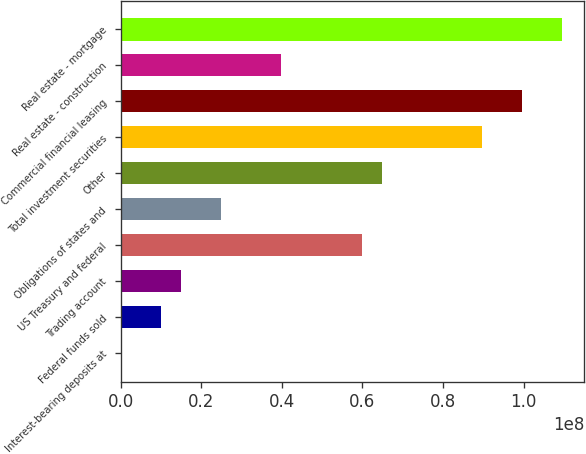Convert chart. <chart><loc_0><loc_0><loc_500><loc_500><bar_chart><fcel>Interest-bearing deposits at<fcel>Federal funds sold<fcel>Trading account<fcel>US Treasury and federal<fcel>Obligations of states and<fcel>Other<fcel>Total investment securities<fcel>Commercial financial leasing<fcel>Real estate - construction<fcel>Real estate - mortgage<nl><fcel>13194<fcel>9.97577e+06<fcel>1.49571e+07<fcel>5.97887e+07<fcel>2.49196e+07<fcel>6.47699e+07<fcel>8.96764e+07<fcel>9.9639e+07<fcel>3.98635e+07<fcel>1.09602e+08<nl></chart> 